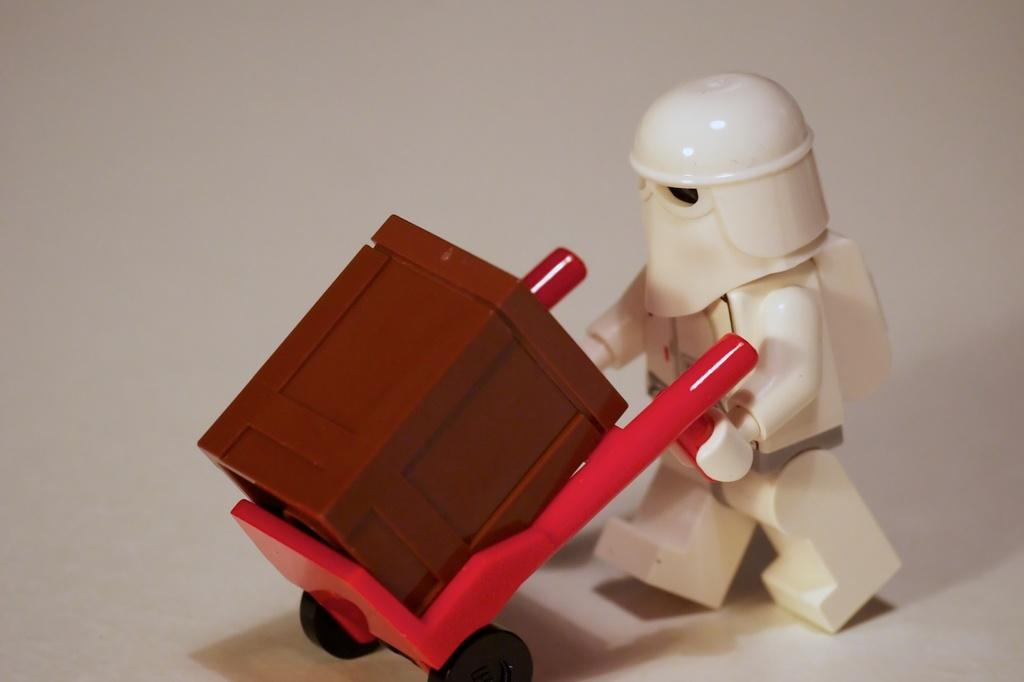What is the color of the toy in the image? The toy in the image is white. Can you describe the trolley in the image? The trolley in the image is red with black wheels. What is the color of the box in the image? The box in the image is brown. What is the color of the background in the image? The background of the image is white. How does the toy attack the trolley in the image? There is no attack or motion between the toy and the trolley in the image; they are separate objects. 